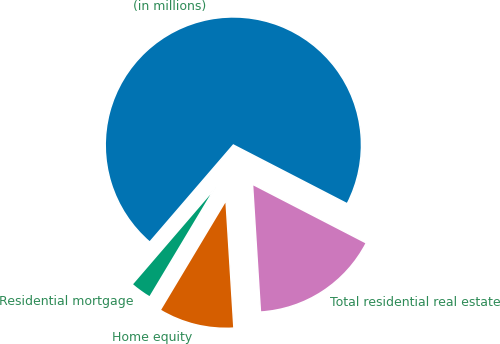<chart> <loc_0><loc_0><loc_500><loc_500><pie_chart><fcel>(in millions)<fcel>Residential mortgage<fcel>Home equity<fcel>Total residential real estate<nl><fcel>71.27%<fcel>2.72%<fcel>9.58%<fcel>16.43%<nl></chart> 